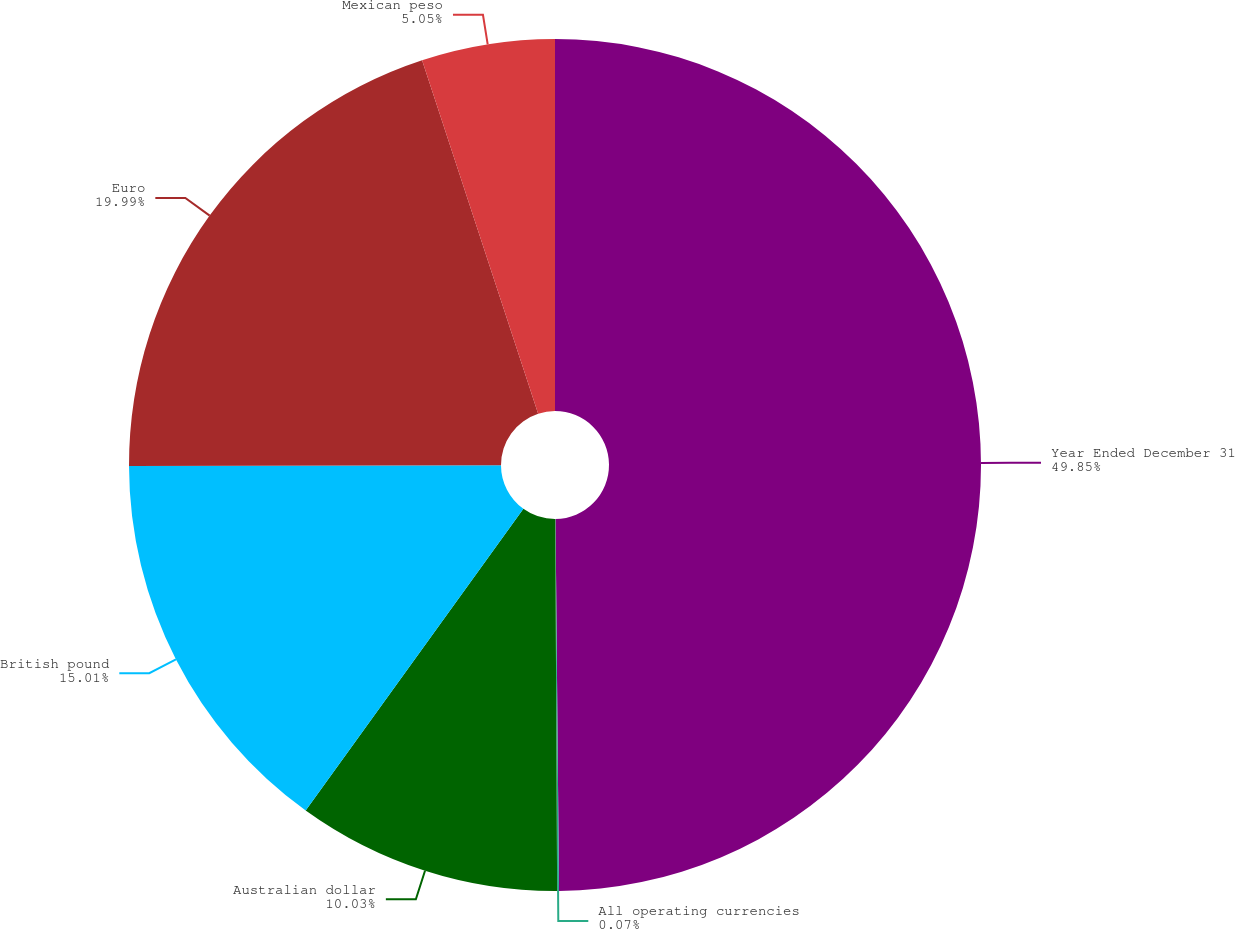Convert chart to OTSL. <chart><loc_0><loc_0><loc_500><loc_500><pie_chart><fcel>Year Ended December 31<fcel>All operating currencies<fcel>Australian dollar<fcel>British pound<fcel>Euro<fcel>Mexican peso<nl><fcel>49.85%<fcel>0.07%<fcel>10.03%<fcel>15.01%<fcel>19.99%<fcel>5.05%<nl></chart> 